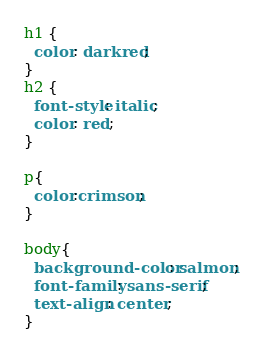<code> <loc_0><loc_0><loc_500><loc_500><_CSS_>h1 {
  color: darkred;
}
h2 {
  font-style: italic;
  color: red;
}

p{
  color:crimson;
}

body{
  background-color: salmon;
  font-family: sans-serif;
  text-align: center;
}</code> 